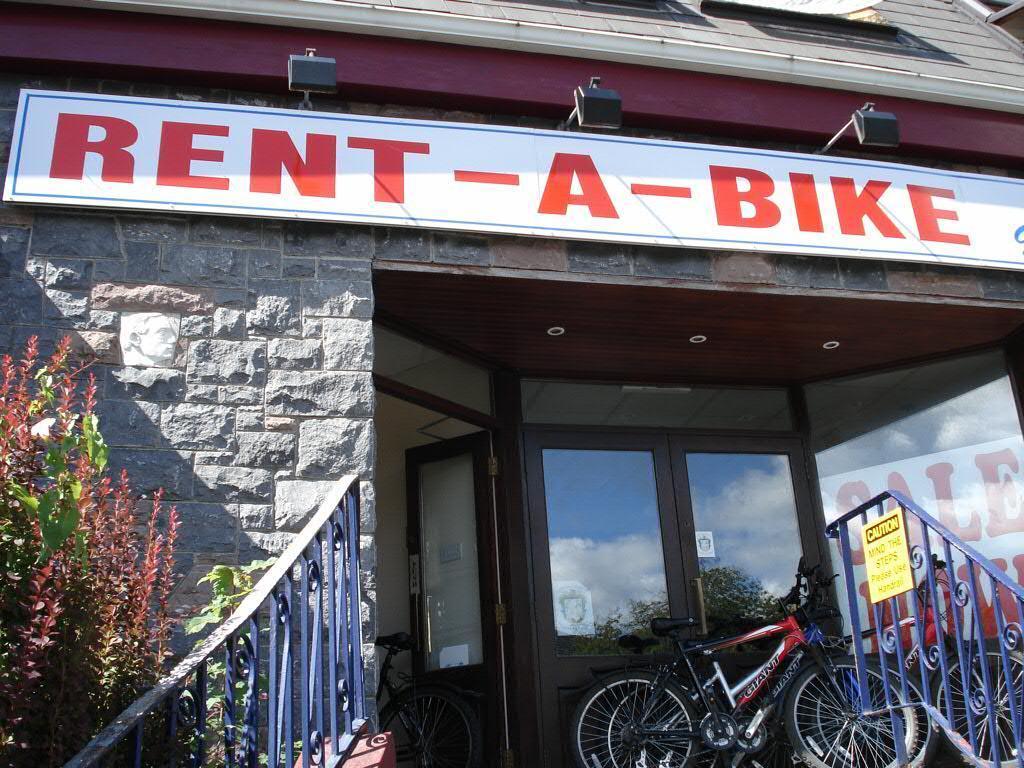Could you give a brief overview of what you see in this image? In this picture I can see a building in front and on the building I see boards on which something is written and I see the railing on the both sides of this image and I see few cycles in front and on the left side of this image I see plants and I see a yellow color board on the right of this image and I see something is written on it. 